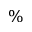Convert formula to latex. <formula><loc_0><loc_0><loc_500><loc_500>\%</formula> 